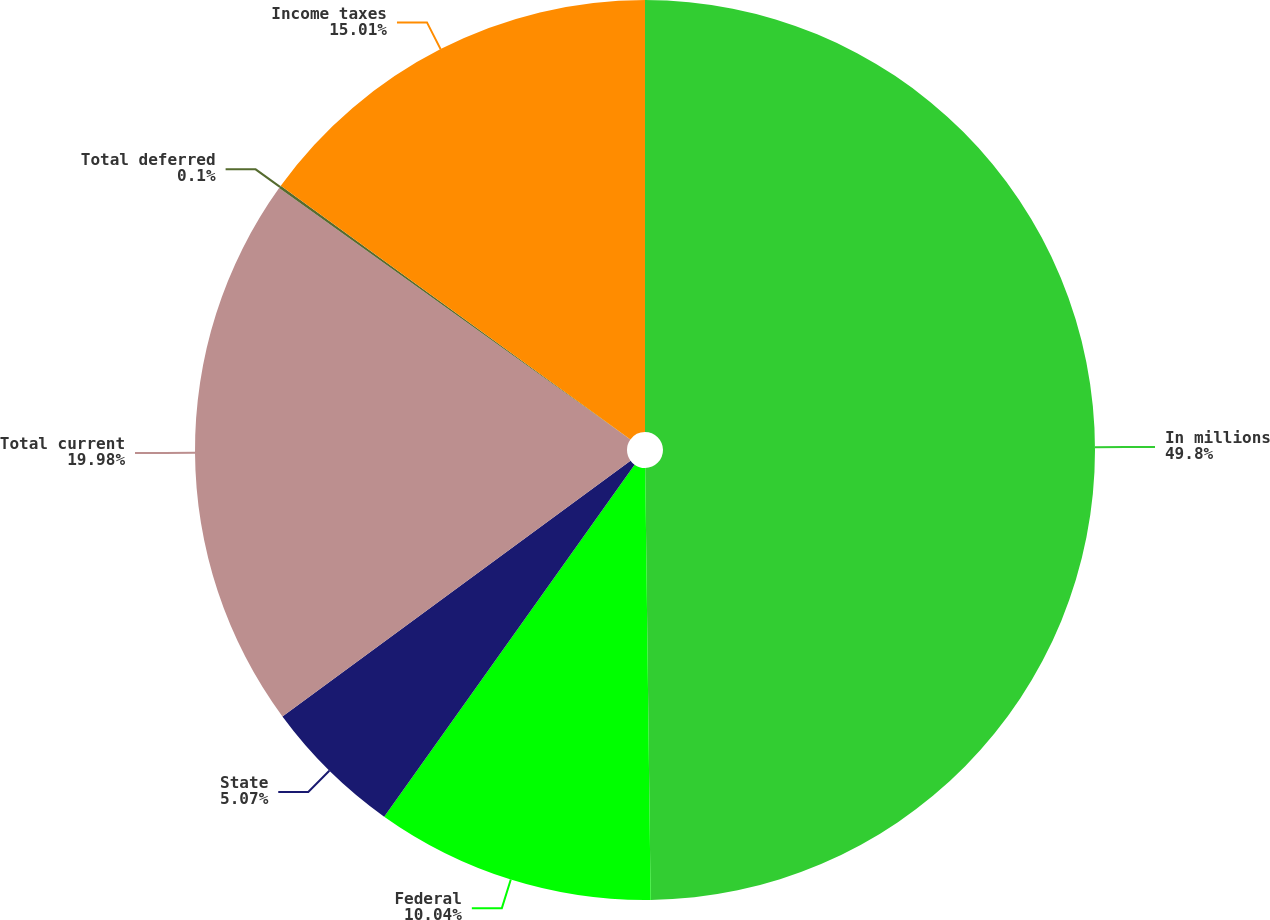Convert chart. <chart><loc_0><loc_0><loc_500><loc_500><pie_chart><fcel>In millions<fcel>Federal<fcel>State<fcel>Total current<fcel>Total deferred<fcel>Income taxes<nl><fcel>49.8%<fcel>10.04%<fcel>5.07%<fcel>19.98%<fcel>0.1%<fcel>15.01%<nl></chart> 